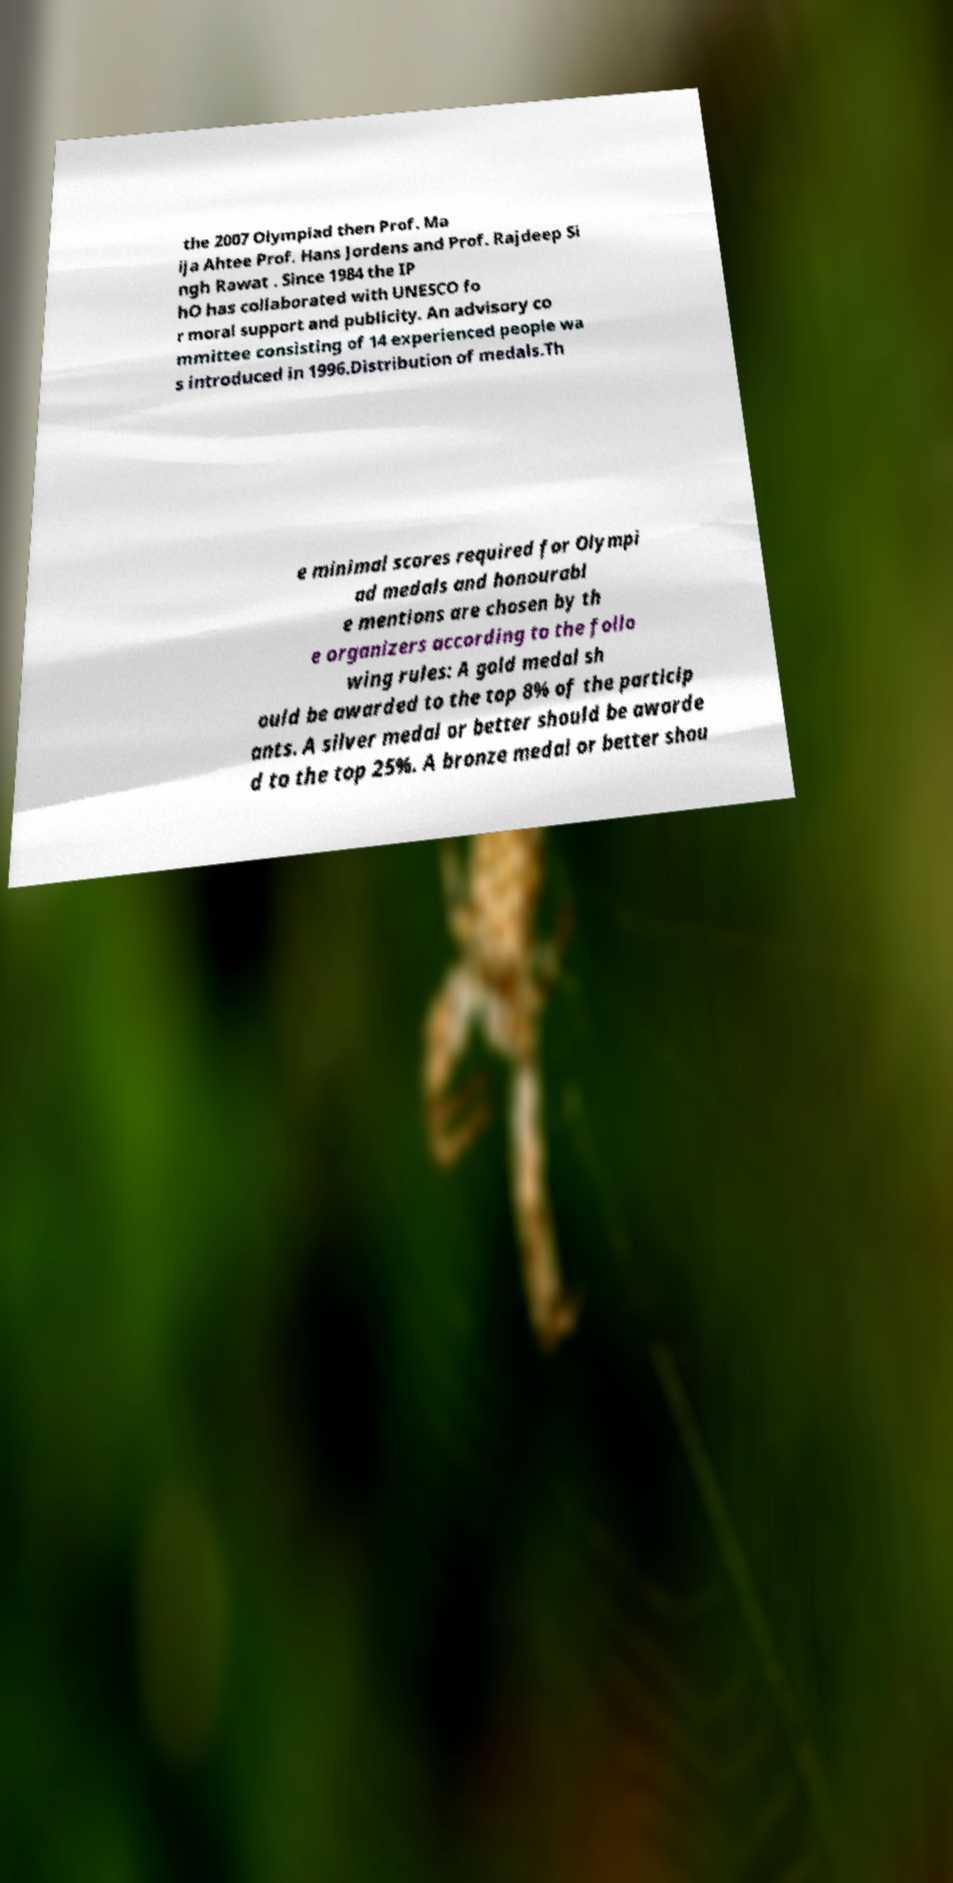Could you assist in decoding the text presented in this image and type it out clearly? the 2007 Olympiad then Prof. Ma ija Ahtee Prof. Hans Jordens and Prof. Rajdeep Si ngh Rawat . Since 1984 the IP hO has collaborated with UNESCO fo r moral support and publicity. An advisory co mmittee consisting of 14 experienced people wa s introduced in 1996.Distribution of medals.Th e minimal scores required for Olympi ad medals and honourabl e mentions are chosen by th e organizers according to the follo wing rules: A gold medal sh ould be awarded to the top 8% of the particip ants. A silver medal or better should be awarde d to the top 25%. A bronze medal or better shou 